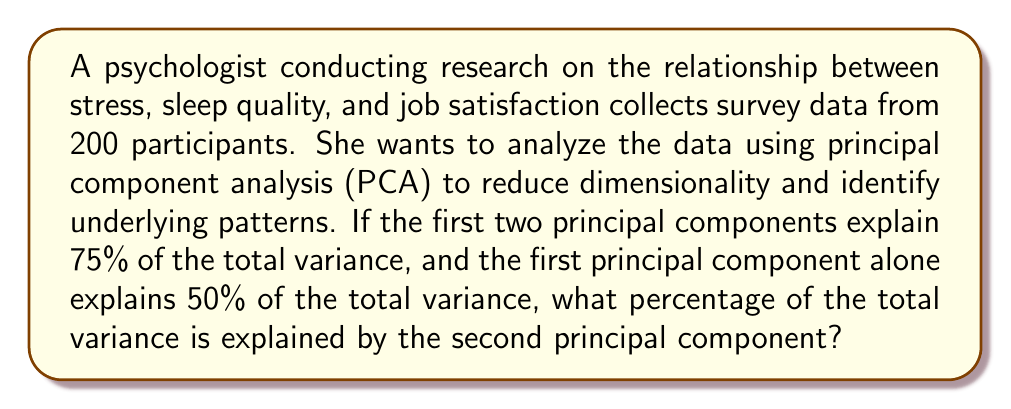Can you solve this math problem? Let's approach this step-by-step:

1) First, we need to understand what the question is asking:
   - We have two principal components (PC1 and PC2)
   - Together, PC1 and PC2 explain 75% of the total variance
   - PC1 alone explains 50% of the total variance
   - We need to find how much variance PC2 explains

2) Let's define our variables:
   - Let $x$ be the percentage of variance explained by PC2

3) We can set up an equation based on the information given:
   $$ 50\% + x = 75\% $$

4) Now, we can solve for $x$:
   $$ x = 75\% - 50\% $$
   $$ x = 25\% $$

5) Therefore, the second principal component (PC2) explains 25% of the total variance.

This analysis helps the psychologist understand the underlying structure of her data, potentially revealing that two major factors (corresponding to PC1 and PC2) account for a large portion of the variation in stress, sleep quality, and job satisfaction among the participants.
Answer: 25% 